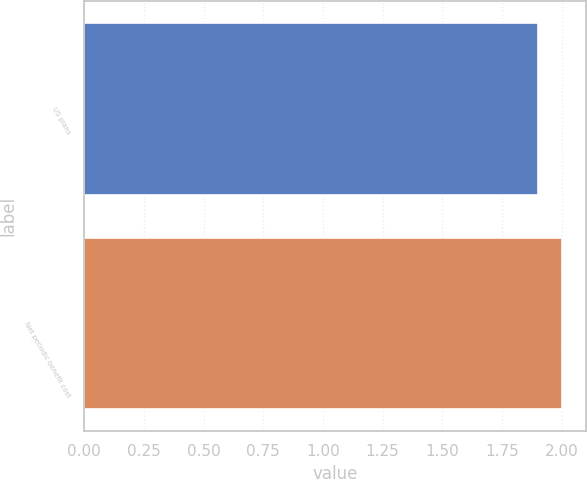Convert chart. <chart><loc_0><loc_0><loc_500><loc_500><bar_chart><fcel>US plans<fcel>Net periodic benefit cost<nl><fcel>1.9<fcel>2<nl></chart> 